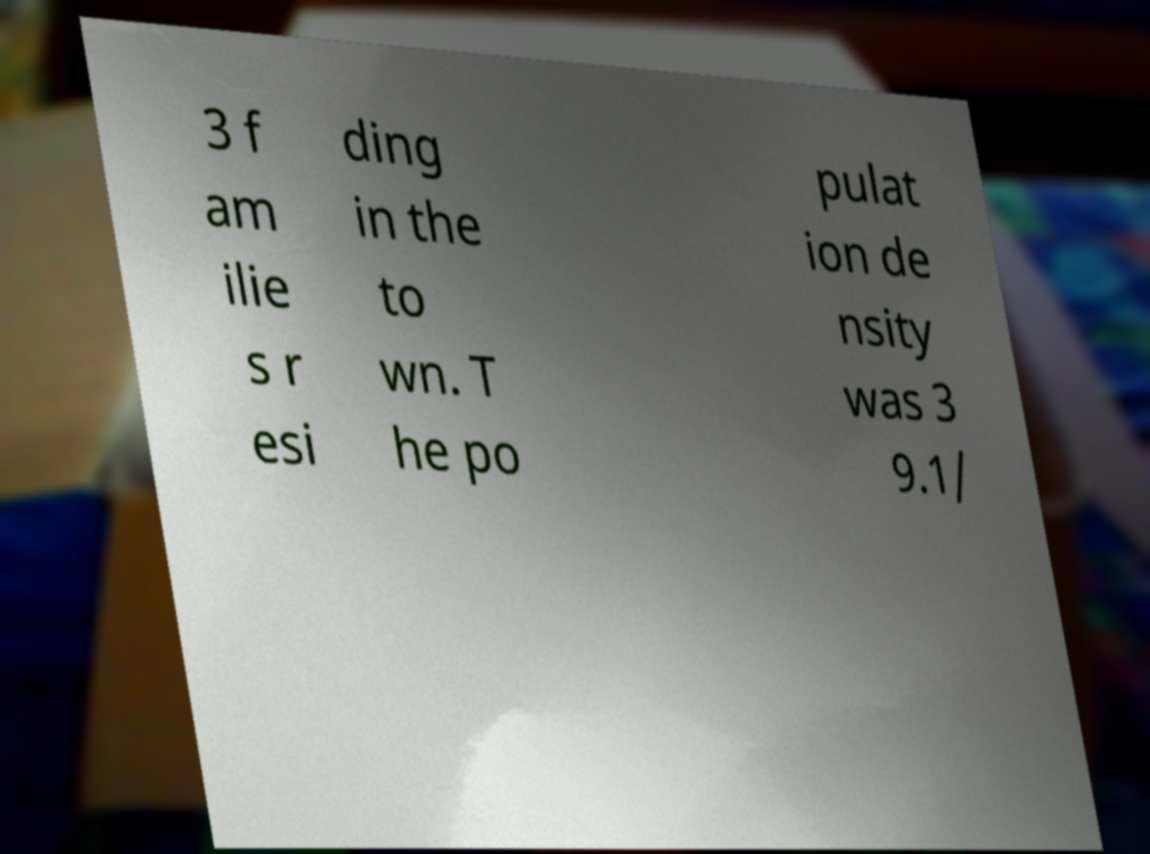Can you accurately transcribe the text from the provided image for me? 3 f am ilie s r esi ding in the to wn. T he po pulat ion de nsity was 3 9.1/ 